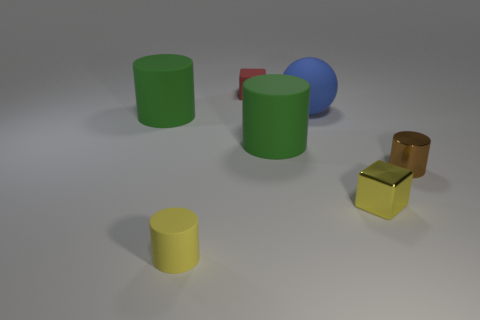Subtract all tiny metal cylinders. How many cylinders are left? 3 Add 2 metal objects. How many objects exist? 9 Subtract all green balls. How many green cylinders are left? 2 Subtract 2 cylinders. How many cylinders are left? 2 Subtract all balls. How many objects are left? 6 Subtract all yellow cylinders. How many cylinders are left? 3 Add 1 brown metal cylinders. How many brown metal cylinders are left? 2 Add 4 big rubber balls. How many big rubber balls exist? 5 Subtract 0 gray cylinders. How many objects are left? 7 Subtract all gray cylinders. Subtract all red cubes. How many cylinders are left? 4 